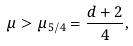Convert formula to latex. <formula><loc_0><loc_0><loc_500><loc_500>\mu > \mu _ { 5 / 4 } = \frac { d + 2 } { 4 } ,</formula> 